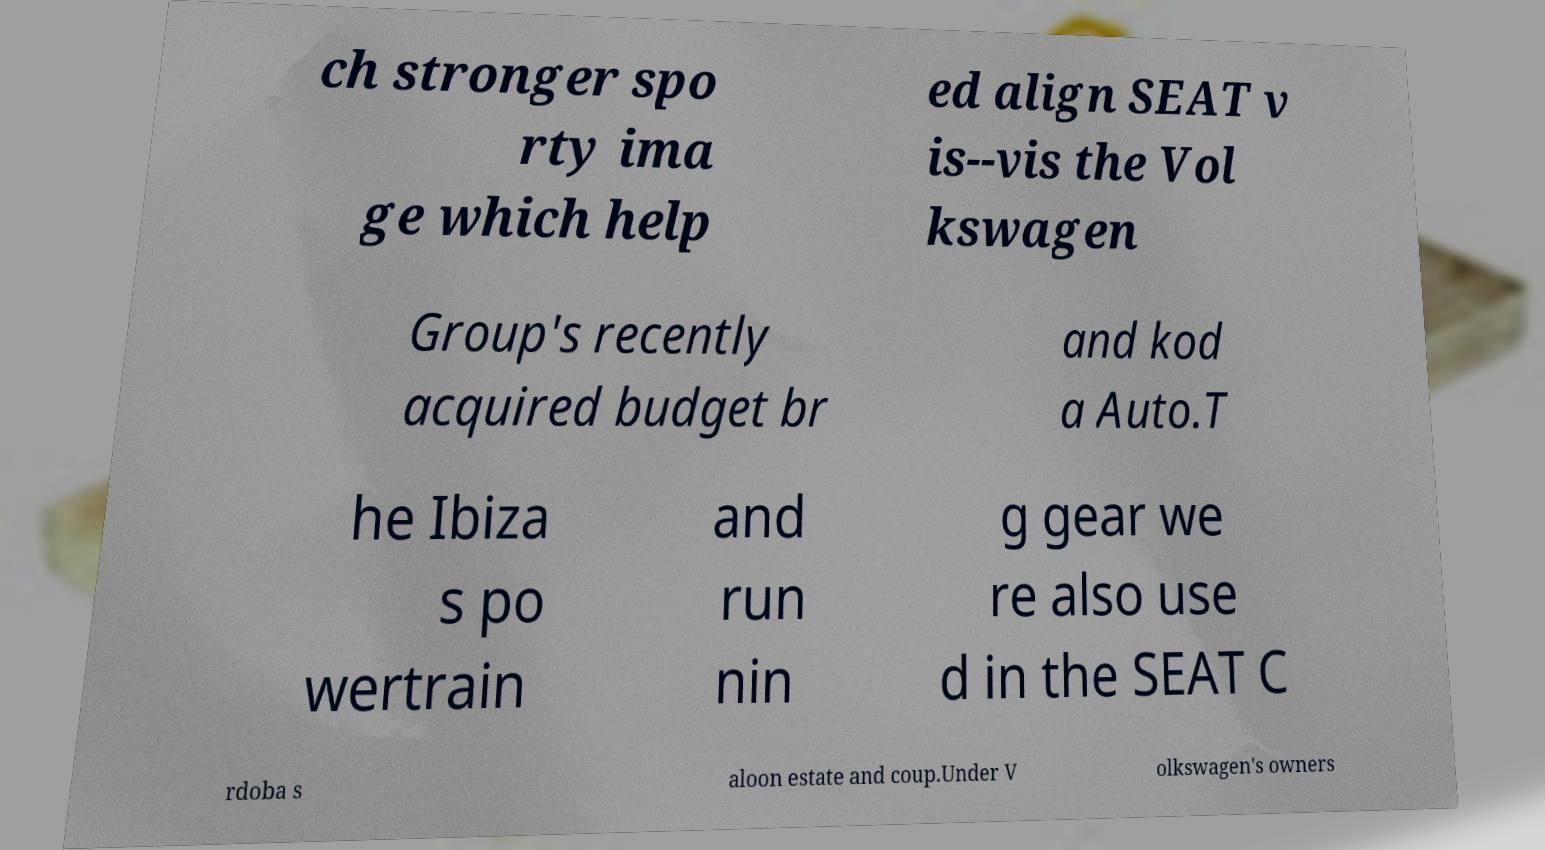Can you accurately transcribe the text from the provided image for me? ch stronger spo rty ima ge which help ed align SEAT v is--vis the Vol kswagen Group's recently acquired budget br and kod a Auto.T he Ibiza s po wertrain and run nin g gear we re also use d in the SEAT C rdoba s aloon estate and coup.Under V olkswagen's owners 